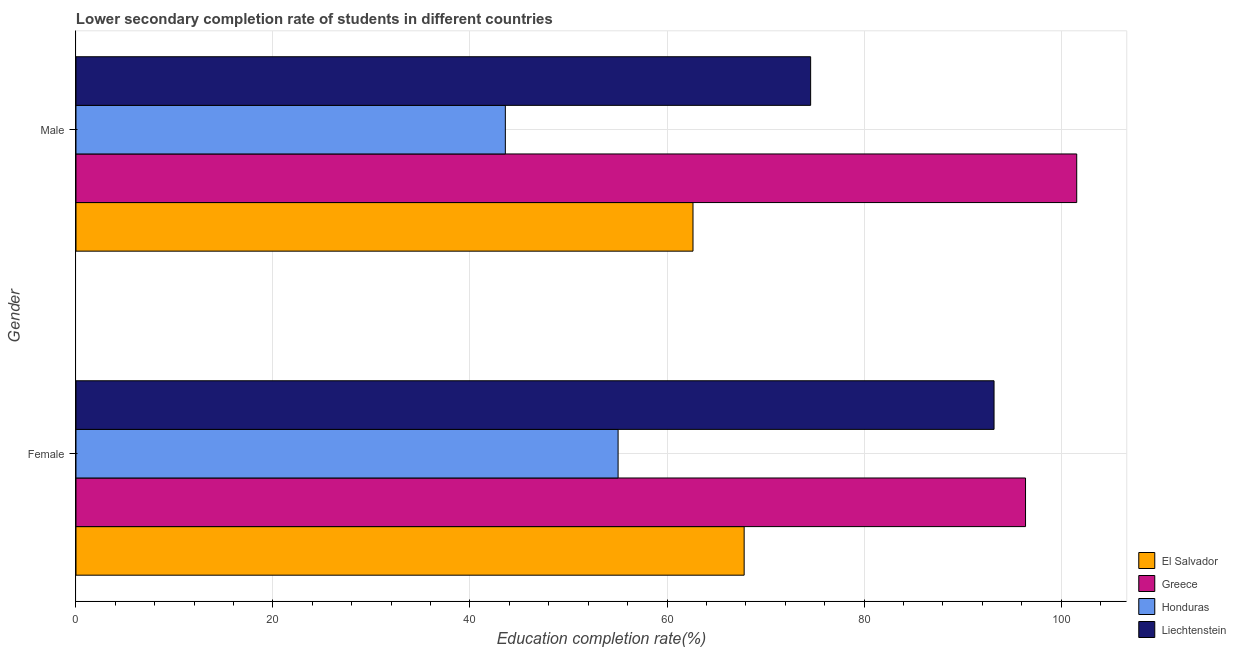How many different coloured bars are there?
Give a very brief answer. 4. Are the number of bars per tick equal to the number of legend labels?
Offer a terse response. Yes. How many bars are there on the 2nd tick from the top?
Your answer should be compact. 4. How many bars are there on the 1st tick from the bottom?
Your response must be concise. 4. What is the education completion rate of male students in Greece?
Ensure brevity in your answer.  101.6. Across all countries, what is the maximum education completion rate of female students?
Give a very brief answer. 96.4. Across all countries, what is the minimum education completion rate of female students?
Your response must be concise. 55.03. In which country was the education completion rate of female students maximum?
Offer a terse response. Greece. In which country was the education completion rate of female students minimum?
Make the answer very short. Honduras. What is the total education completion rate of male students in the graph?
Offer a very short reply. 282.41. What is the difference between the education completion rate of male students in Honduras and that in El Salvador?
Your response must be concise. -19.05. What is the difference between the education completion rate of male students in Honduras and the education completion rate of female students in Liechtenstein?
Ensure brevity in your answer.  -49.62. What is the average education completion rate of male students per country?
Ensure brevity in your answer.  70.6. What is the difference between the education completion rate of female students and education completion rate of male students in Honduras?
Your answer should be compact. 11.45. In how many countries, is the education completion rate of female students greater than 32 %?
Keep it short and to the point. 4. What is the ratio of the education completion rate of female students in Greece to that in Liechtenstein?
Provide a succinct answer. 1.03. Is the education completion rate of male students in Greece less than that in El Salvador?
Provide a succinct answer. No. What does the 3rd bar from the top in Female represents?
Your answer should be compact. Greece. What does the 4th bar from the bottom in Male represents?
Give a very brief answer. Liechtenstein. Are all the bars in the graph horizontal?
Offer a terse response. Yes. Does the graph contain any zero values?
Provide a succinct answer. No. How are the legend labels stacked?
Your response must be concise. Vertical. What is the title of the graph?
Offer a terse response. Lower secondary completion rate of students in different countries. What is the label or title of the X-axis?
Keep it short and to the point. Education completion rate(%). What is the Education completion rate(%) in El Salvador in Female?
Your answer should be compact. 67.83. What is the Education completion rate(%) in Greece in Female?
Offer a terse response. 96.4. What is the Education completion rate(%) of Honduras in Female?
Give a very brief answer. 55.03. What is the Education completion rate(%) in Liechtenstein in Female?
Give a very brief answer. 93.2. What is the Education completion rate(%) in El Salvador in Male?
Give a very brief answer. 62.64. What is the Education completion rate(%) of Greece in Male?
Give a very brief answer. 101.6. What is the Education completion rate(%) of Honduras in Male?
Offer a very short reply. 43.59. What is the Education completion rate(%) of Liechtenstein in Male?
Your answer should be very brief. 74.58. Across all Gender, what is the maximum Education completion rate(%) of El Salvador?
Provide a short and direct response. 67.83. Across all Gender, what is the maximum Education completion rate(%) in Greece?
Your answer should be compact. 101.6. Across all Gender, what is the maximum Education completion rate(%) in Honduras?
Ensure brevity in your answer.  55.03. Across all Gender, what is the maximum Education completion rate(%) of Liechtenstein?
Provide a short and direct response. 93.2. Across all Gender, what is the minimum Education completion rate(%) of El Salvador?
Your response must be concise. 62.64. Across all Gender, what is the minimum Education completion rate(%) of Greece?
Your response must be concise. 96.4. Across all Gender, what is the minimum Education completion rate(%) of Honduras?
Offer a terse response. 43.59. Across all Gender, what is the minimum Education completion rate(%) in Liechtenstein?
Provide a short and direct response. 74.58. What is the total Education completion rate(%) of El Salvador in the graph?
Your answer should be very brief. 130.47. What is the total Education completion rate(%) in Greece in the graph?
Your answer should be compact. 198. What is the total Education completion rate(%) in Honduras in the graph?
Keep it short and to the point. 98.62. What is the total Education completion rate(%) of Liechtenstein in the graph?
Ensure brevity in your answer.  167.79. What is the difference between the Education completion rate(%) in El Salvador in Female and that in Male?
Offer a very short reply. 5.19. What is the difference between the Education completion rate(%) of Greece in Female and that in Male?
Your answer should be very brief. -5.2. What is the difference between the Education completion rate(%) in Honduras in Female and that in Male?
Your answer should be very brief. 11.45. What is the difference between the Education completion rate(%) of Liechtenstein in Female and that in Male?
Provide a succinct answer. 18.62. What is the difference between the Education completion rate(%) in El Salvador in Female and the Education completion rate(%) in Greece in Male?
Your answer should be very brief. -33.76. What is the difference between the Education completion rate(%) in El Salvador in Female and the Education completion rate(%) in Honduras in Male?
Your answer should be compact. 24.25. What is the difference between the Education completion rate(%) in El Salvador in Female and the Education completion rate(%) in Liechtenstein in Male?
Provide a succinct answer. -6.75. What is the difference between the Education completion rate(%) of Greece in Female and the Education completion rate(%) of Honduras in Male?
Ensure brevity in your answer.  52.81. What is the difference between the Education completion rate(%) in Greece in Female and the Education completion rate(%) in Liechtenstein in Male?
Your response must be concise. 21.82. What is the difference between the Education completion rate(%) of Honduras in Female and the Education completion rate(%) of Liechtenstein in Male?
Provide a succinct answer. -19.55. What is the average Education completion rate(%) of El Salvador per Gender?
Your answer should be very brief. 65.24. What is the average Education completion rate(%) in Greece per Gender?
Your answer should be very brief. 99. What is the average Education completion rate(%) of Honduras per Gender?
Keep it short and to the point. 49.31. What is the average Education completion rate(%) in Liechtenstein per Gender?
Offer a terse response. 83.89. What is the difference between the Education completion rate(%) in El Salvador and Education completion rate(%) in Greece in Female?
Your answer should be very brief. -28.57. What is the difference between the Education completion rate(%) in El Salvador and Education completion rate(%) in Honduras in Female?
Make the answer very short. 12.8. What is the difference between the Education completion rate(%) in El Salvador and Education completion rate(%) in Liechtenstein in Female?
Your answer should be very brief. -25.37. What is the difference between the Education completion rate(%) of Greece and Education completion rate(%) of Honduras in Female?
Your answer should be very brief. 41.37. What is the difference between the Education completion rate(%) of Greece and Education completion rate(%) of Liechtenstein in Female?
Your answer should be very brief. 3.2. What is the difference between the Education completion rate(%) of Honduras and Education completion rate(%) of Liechtenstein in Female?
Your answer should be compact. -38.17. What is the difference between the Education completion rate(%) in El Salvador and Education completion rate(%) in Greece in Male?
Your response must be concise. -38.96. What is the difference between the Education completion rate(%) in El Salvador and Education completion rate(%) in Honduras in Male?
Your answer should be compact. 19.05. What is the difference between the Education completion rate(%) of El Salvador and Education completion rate(%) of Liechtenstein in Male?
Keep it short and to the point. -11.94. What is the difference between the Education completion rate(%) of Greece and Education completion rate(%) of Honduras in Male?
Make the answer very short. 58.01. What is the difference between the Education completion rate(%) in Greece and Education completion rate(%) in Liechtenstein in Male?
Offer a terse response. 27.01. What is the difference between the Education completion rate(%) in Honduras and Education completion rate(%) in Liechtenstein in Male?
Offer a very short reply. -30.99. What is the ratio of the Education completion rate(%) in El Salvador in Female to that in Male?
Your response must be concise. 1.08. What is the ratio of the Education completion rate(%) in Greece in Female to that in Male?
Your response must be concise. 0.95. What is the ratio of the Education completion rate(%) of Honduras in Female to that in Male?
Offer a very short reply. 1.26. What is the ratio of the Education completion rate(%) of Liechtenstein in Female to that in Male?
Your answer should be compact. 1.25. What is the difference between the highest and the second highest Education completion rate(%) of El Salvador?
Keep it short and to the point. 5.19. What is the difference between the highest and the second highest Education completion rate(%) in Greece?
Provide a short and direct response. 5.2. What is the difference between the highest and the second highest Education completion rate(%) of Honduras?
Provide a short and direct response. 11.45. What is the difference between the highest and the second highest Education completion rate(%) in Liechtenstein?
Give a very brief answer. 18.62. What is the difference between the highest and the lowest Education completion rate(%) of El Salvador?
Your answer should be compact. 5.19. What is the difference between the highest and the lowest Education completion rate(%) of Greece?
Provide a short and direct response. 5.2. What is the difference between the highest and the lowest Education completion rate(%) in Honduras?
Your response must be concise. 11.45. What is the difference between the highest and the lowest Education completion rate(%) in Liechtenstein?
Offer a very short reply. 18.62. 